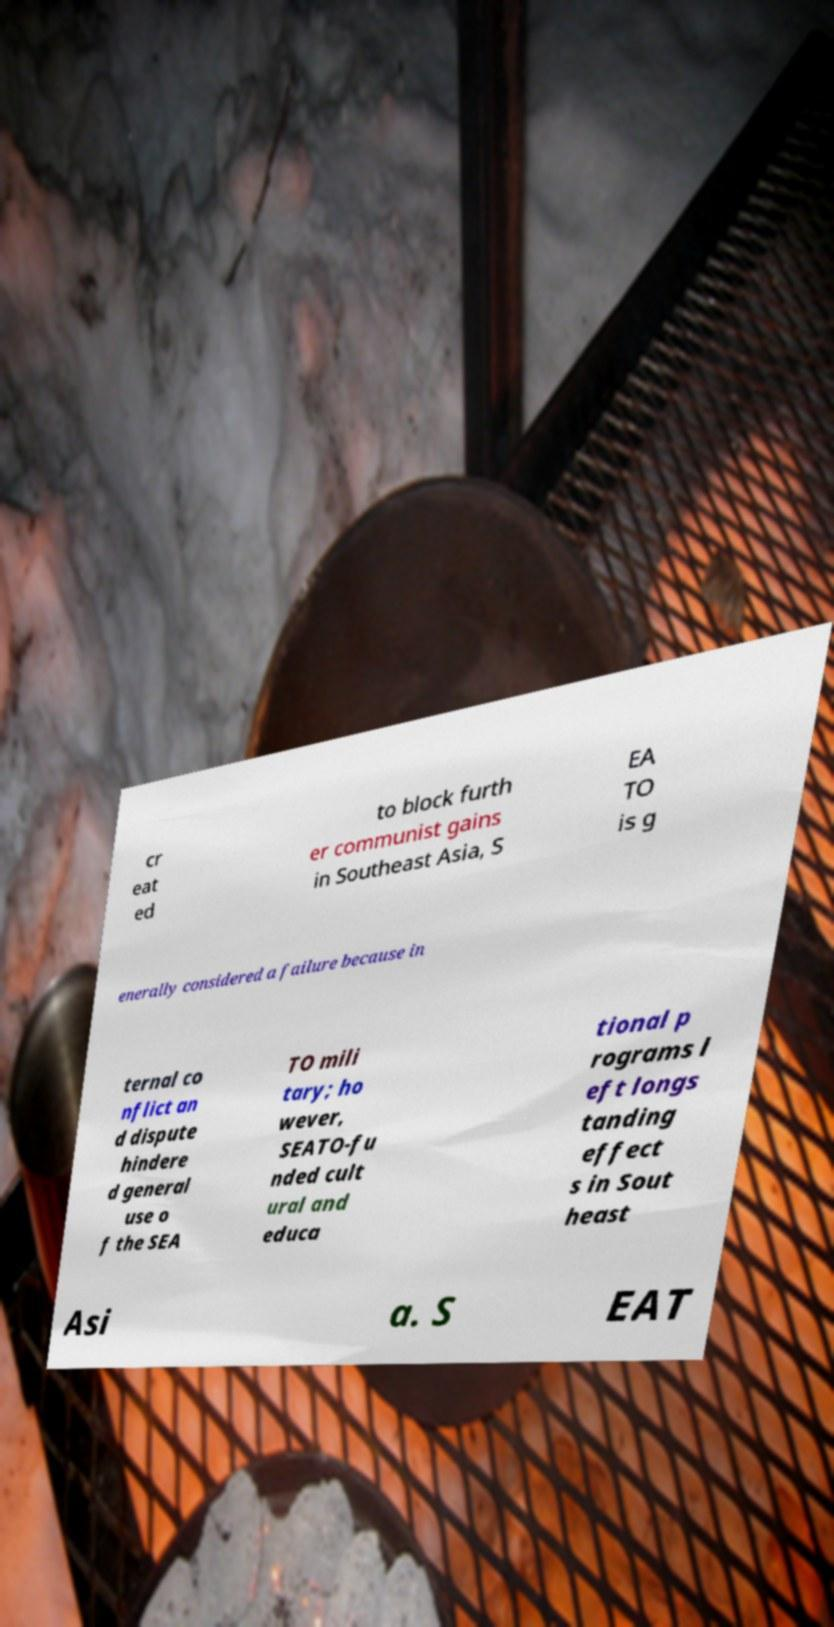For documentation purposes, I need the text within this image transcribed. Could you provide that? cr eat ed to block furth er communist gains in Southeast Asia, S EA TO is g enerally considered a failure because in ternal co nflict an d dispute hindere d general use o f the SEA TO mili tary; ho wever, SEATO-fu nded cult ural and educa tional p rograms l eft longs tanding effect s in Sout heast Asi a. S EAT 